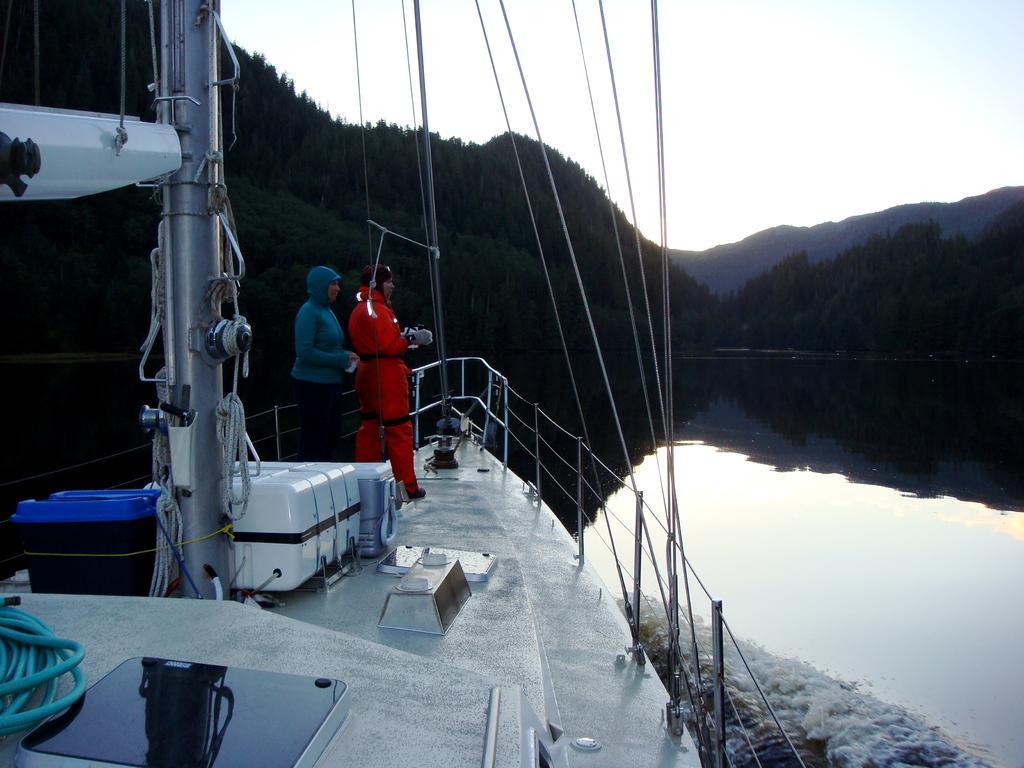How would you summarize this image in a sentence or two? In this image I can see 2 people standing in a ship. There are ropes and fence. There is water and trees at the back. There is sky at the top. 